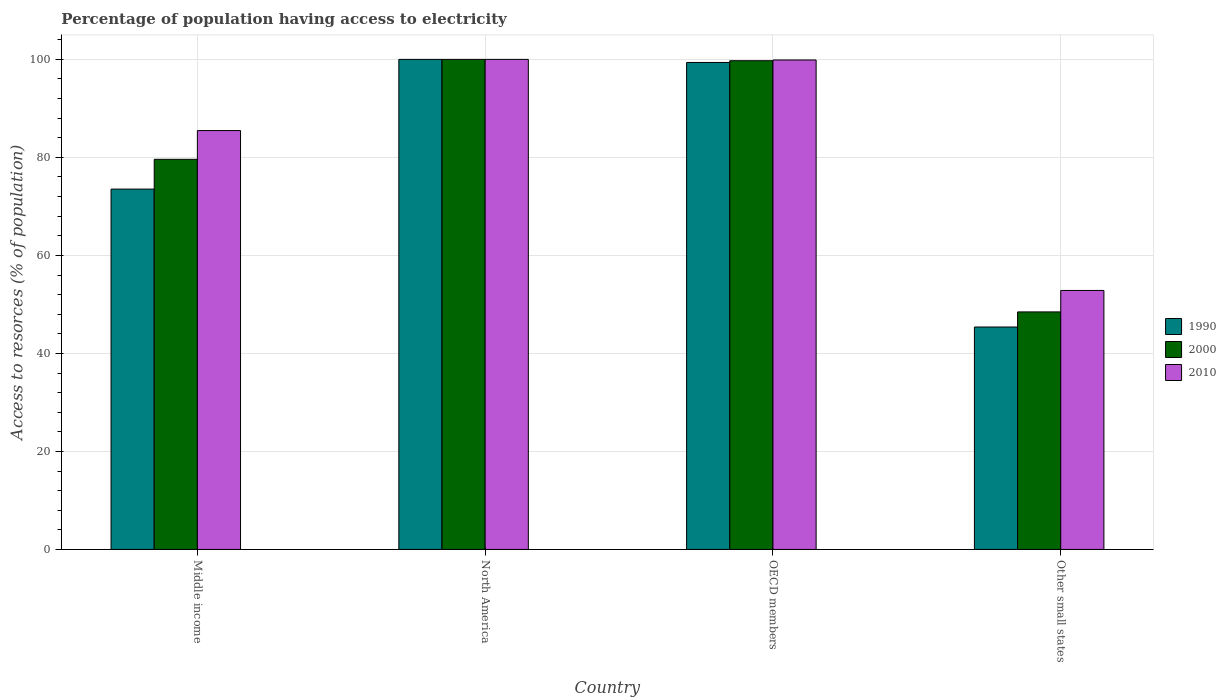How many different coloured bars are there?
Give a very brief answer. 3. How many groups of bars are there?
Provide a short and direct response. 4. Are the number of bars on each tick of the X-axis equal?
Ensure brevity in your answer.  Yes. How many bars are there on the 2nd tick from the left?
Your answer should be compact. 3. What is the label of the 4th group of bars from the left?
Ensure brevity in your answer.  Other small states. What is the percentage of population having access to electricity in 1990 in North America?
Give a very brief answer. 100. Across all countries, what is the maximum percentage of population having access to electricity in 2000?
Your answer should be compact. 100. Across all countries, what is the minimum percentage of population having access to electricity in 1990?
Offer a very short reply. 45.39. In which country was the percentage of population having access to electricity in 2010 minimum?
Make the answer very short. Other small states. What is the total percentage of population having access to electricity in 1990 in the graph?
Your answer should be compact. 318.29. What is the difference between the percentage of population having access to electricity in 2010 in Middle income and that in OECD members?
Ensure brevity in your answer.  -14.41. What is the difference between the percentage of population having access to electricity in 1990 in North America and the percentage of population having access to electricity in 2010 in Middle income?
Keep it short and to the point. 14.53. What is the average percentage of population having access to electricity in 1990 per country?
Give a very brief answer. 79.57. What is the difference between the percentage of population having access to electricity of/in 2000 and percentage of population having access to electricity of/in 2010 in Other small states?
Offer a terse response. -4.38. In how many countries, is the percentage of population having access to electricity in 1990 greater than 64 %?
Provide a short and direct response. 3. What is the ratio of the percentage of population having access to electricity in 1990 in North America to that in OECD members?
Offer a terse response. 1.01. Is the percentage of population having access to electricity in 1990 in OECD members less than that in Other small states?
Your answer should be very brief. No. Is the difference between the percentage of population having access to electricity in 2000 in Middle income and North America greater than the difference between the percentage of population having access to electricity in 2010 in Middle income and North America?
Offer a very short reply. No. What is the difference between the highest and the second highest percentage of population having access to electricity in 2010?
Provide a succinct answer. -0.12. What is the difference between the highest and the lowest percentage of population having access to electricity in 1990?
Make the answer very short. 54.61. What does the 3rd bar from the left in OECD members represents?
Your answer should be very brief. 2010. What does the 2nd bar from the right in Middle income represents?
Make the answer very short. 2000. What is the difference between two consecutive major ticks on the Y-axis?
Your answer should be very brief. 20. Are the values on the major ticks of Y-axis written in scientific E-notation?
Make the answer very short. No. What is the title of the graph?
Your answer should be very brief. Percentage of population having access to electricity. What is the label or title of the Y-axis?
Give a very brief answer. Access to resorces (% of population). What is the Access to resorces (% of population) of 1990 in Middle income?
Offer a very short reply. 73.53. What is the Access to resorces (% of population) of 2000 in Middle income?
Provide a short and direct response. 79.61. What is the Access to resorces (% of population) in 2010 in Middle income?
Keep it short and to the point. 85.47. What is the Access to resorces (% of population) in 1990 in North America?
Your response must be concise. 100. What is the Access to resorces (% of population) of 2000 in North America?
Your answer should be compact. 100. What is the Access to resorces (% of population) in 2010 in North America?
Your answer should be very brief. 100. What is the Access to resorces (% of population) of 1990 in OECD members?
Offer a terse response. 99.37. What is the Access to resorces (% of population) in 2000 in OECD members?
Give a very brief answer. 99.72. What is the Access to resorces (% of population) in 2010 in OECD members?
Make the answer very short. 99.88. What is the Access to resorces (% of population) of 1990 in Other small states?
Keep it short and to the point. 45.39. What is the Access to resorces (% of population) of 2000 in Other small states?
Provide a short and direct response. 48.47. What is the Access to resorces (% of population) in 2010 in Other small states?
Your answer should be compact. 52.85. Across all countries, what is the maximum Access to resorces (% of population) of 1990?
Offer a terse response. 100. Across all countries, what is the maximum Access to resorces (% of population) in 2000?
Your response must be concise. 100. Across all countries, what is the minimum Access to resorces (% of population) of 1990?
Keep it short and to the point. 45.39. Across all countries, what is the minimum Access to resorces (% of population) of 2000?
Ensure brevity in your answer.  48.47. Across all countries, what is the minimum Access to resorces (% of population) in 2010?
Ensure brevity in your answer.  52.85. What is the total Access to resorces (% of population) of 1990 in the graph?
Your answer should be very brief. 318.29. What is the total Access to resorces (% of population) of 2000 in the graph?
Keep it short and to the point. 327.8. What is the total Access to resorces (% of population) of 2010 in the graph?
Your answer should be compact. 338.2. What is the difference between the Access to resorces (% of population) in 1990 in Middle income and that in North America?
Provide a succinct answer. -26.47. What is the difference between the Access to resorces (% of population) in 2000 in Middle income and that in North America?
Offer a terse response. -20.39. What is the difference between the Access to resorces (% of population) of 2010 in Middle income and that in North America?
Ensure brevity in your answer.  -14.53. What is the difference between the Access to resorces (% of population) of 1990 in Middle income and that in OECD members?
Give a very brief answer. -25.84. What is the difference between the Access to resorces (% of population) of 2000 in Middle income and that in OECD members?
Give a very brief answer. -20.12. What is the difference between the Access to resorces (% of population) in 2010 in Middle income and that in OECD members?
Provide a short and direct response. -14.41. What is the difference between the Access to resorces (% of population) in 1990 in Middle income and that in Other small states?
Your answer should be compact. 28.14. What is the difference between the Access to resorces (% of population) of 2000 in Middle income and that in Other small states?
Make the answer very short. 31.14. What is the difference between the Access to resorces (% of population) of 2010 in Middle income and that in Other small states?
Provide a short and direct response. 32.62. What is the difference between the Access to resorces (% of population) of 1990 in North America and that in OECD members?
Provide a succinct answer. 0.63. What is the difference between the Access to resorces (% of population) of 2000 in North America and that in OECD members?
Your answer should be very brief. 0.28. What is the difference between the Access to resorces (% of population) of 2010 in North America and that in OECD members?
Your answer should be compact. 0.12. What is the difference between the Access to resorces (% of population) of 1990 in North America and that in Other small states?
Provide a succinct answer. 54.61. What is the difference between the Access to resorces (% of population) of 2000 in North America and that in Other small states?
Give a very brief answer. 51.53. What is the difference between the Access to resorces (% of population) in 2010 in North America and that in Other small states?
Ensure brevity in your answer.  47.15. What is the difference between the Access to resorces (% of population) in 1990 in OECD members and that in Other small states?
Offer a very short reply. 53.98. What is the difference between the Access to resorces (% of population) of 2000 in OECD members and that in Other small states?
Give a very brief answer. 51.25. What is the difference between the Access to resorces (% of population) in 2010 in OECD members and that in Other small states?
Give a very brief answer. 47.03. What is the difference between the Access to resorces (% of population) in 1990 in Middle income and the Access to resorces (% of population) in 2000 in North America?
Offer a very short reply. -26.47. What is the difference between the Access to resorces (% of population) in 1990 in Middle income and the Access to resorces (% of population) in 2010 in North America?
Keep it short and to the point. -26.47. What is the difference between the Access to resorces (% of population) in 2000 in Middle income and the Access to resorces (% of population) in 2010 in North America?
Offer a terse response. -20.39. What is the difference between the Access to resorces (% of population) in 1990 in Middle income and the Access to resorces (% of population) in 2000 in OECD members?
Provide a short and direct response. -26.19. What is the difference between the Access to resorces (% of population) in 1990 in Middle income and the Access to resorces (% of population) in 2010 in OECD members?
Your answer should be compact. -26.35. What is the difference between the Access to resorces (% of population) of 2000 in Middle income and the Access to resorces (% of population) of 2010 in OECD members?
Ensure brevity in your answer.  -20.27. What is the difference between the Access to resorces (% of population) in 1990 in Middle income and the Access to resorces (% of population) in 2000 in Other small states?
Provide a succinct answer. 25.06. What is the difference between the Access to resorces (% of population) in 1990 in Middle income and the Access to resorces (% of population) in 2010 in Other small states?
Your response must be concise. 20.68. What is the difference between the Access to resorces (% of population) of 2000 in Middle income and the Access to resorces (% of population) of 2010 in Other small states?
Provide a short and direct response. 26.76. What is the difference between the Access to resorces (% of population) of 1990 in North America and the Access to resorces (% of population) of 2000 in OECD members?
Give a very brief answer. 0.28. What is the difference between the Access to resorces (% of population) in 1990 in North America and the Access to resorces (% of population) in 2010 in OECD members?
Give a very brief answer. 0.12. What is the difference between the Access to resorces (% of population) in 2000 in North America and the Access to resorces (% of population) in 2010 in OECD members?
Your answer should be compact. 0.12. What is the difference between the Access to resorces (% of population) in 1990 in North America and the Access to resorces (% of population) in 2000 in Other small states?
Make the answer very short. 51.53. What is the difference between the Access to resorces (% of population) of 1990 in North America and the Access to resorces (% of population) of 2010 in Other small states?
Your answer should be compact. 47.15. What is the difference between the Access to resorces (% of population) of 2000 in North America and the Access to resorces (% of population) of 2010 in Other small states?
Your answer should be compact. 47.15. What is the difference between the Access to resorces (% of population) in 1990 in OECD members and the Access to resorces (% of population) in 2000 in Other small states?
Keep it short and to the point. 50.9. What is the difference between the Access to resorces (% of population) in 1990 in OECD members and the Access to resorces (% of population) in 2010 in Other small states?
Your response must be concise. 46.52. What is the difference between the Access to resorces (% of population) in 2000 in OECD members and the Access to resorces (% of population) in 2010 in Other small states?
Your answer should be compact. 46.88. What is the average Access to resorces (% of population) of 1990 per country?
Give a very brief answer. 79.57. What is the average Access to resorces (% of population) in 2000 per country?
Your answer should be very brief. 81.95. What is the average Access to resorces (% of population) in 2010 per country?
Your answer should be very brief. 84.55. What is the difference between the Access to resorces (% of population) in 1990 and Access to resorces (% of population) in 2000 in Middle income?
Provide a short and direct response. -6.08. What is the difference between the Access to resorces (% of population) of 1990 and Access to resorces (% of population) of 2010 in Middle income?
Your answer should be compact. -11.94. What is the difference between the Access to resorces (% of population) in 2000 and Access to resorces (% of population) in 2010 in Middle income?
Provide a short and direct response. -5.87. What is the difference between the Access to resorces (% of population) of 1990 and Access to resorces (% of population) of 2000 in North America?
Your answer should be very brief. 0. What is the difference between the Access to resorces (% of population) of 1990 and Access to resorces (% of population) of 2010 in North America?
Your answer should be very brief. 0. What is the difference between the Access to resorces (% of population) in 1990 and Access to resorces (% of population) in 2000 in OECD members?
Provide a succinct answer. -0.35. What is the difference between the Access to resorces (% of population) of 1990 and Access to resorces (% of population) of 2010 in OECD members?
Offer a terse response. -0.51. What is the difference between the Access to resorces (% of population) of 2000 and Access to resorces (% of population) of 2010 in OECD members?
Provide a short and direct response. -0.15. What is the difference between the Access to resorces (% of population) of 1990 and Access to resorces (% of population) of 2000 in Other small states?
Provide a short and direct response. -3.08. What is the difference between the Access to resorces (% of population) in 1990 and Access to resorces (% of population) in 2010 in Other small states?
Your answer should be compact. -7.46. What is the difference between the Access to resorces (% of population) of 2000 and Access to resorces (% of population) of 2010 in Other small states?
Offer a terse response. -4.38. What is the ratio of the Access to resorces (% of population) in 1990 in Middle income to that in North America?
Give a very brief answer. 0.74. What is the ratio of the Access to resorces (% of population) of 2000 in Middle income to that in North America?
Give a very brief answer. 0.8. What is the ratio of the Access to resorces (% of population) of 2010 in Middle income to that in North America?
Provide a succinct answer. 0.85. What is the ratio of the Access to resorces (% of population) of 1990 in Middle income to that in OECD members?
Give a very brief answer. 0.74. What is the ratio of the Access to resorces (% of population) of 2000 in Middle income to that in OECD members?
Your answer should be very brief. 0.8. What is the ratio of the Access to resorces (% of population) in 2010 in Middle income to that in OECD members?
Provide a short and direct response. 0.86. What is the ratio of the Access to resorces (% of population) in 1990 in Middle income to that in Other small states?
Offer a terse response. 1.62. What is the ratio of the Access to resorces (% of population) of 2000 in Middle income to that in Other small states?
Provide a succinct answer. 1.64. What is the ratio of the Access to resorces (% of population) of 2010 in Middle income to that in Other small states?
Provide a succinct answer. 1.62. What is the ratio of the Access to resorces (% of population) in 1990 in North America to that in OECD members?
Keep it short and to the point. 1.01. What is the ratio of the Access to resorces (% of population) of 1990 in North America to that in Other small states?
Your answer should be very brief. 2.2. What is the ratio of the Access to resorces (% of population) of 2000 in North America to that in Other small states?
Your response must be concise. 2.06. What is the ratio of the Access to resorces (% of population) of 2010 in North America to that in Other small states?
Ensure brevity in your answer.  1.89. What is the ratio of the Access to resorces (% of population) of 1990 in OECD members to that in Other small states?
Your answer should be compact. 2.19. What is the ratio of the Access to resorces (% of population) of 2000 in OECD members to that in Other small states?
Your answer should be compact. 2.06. What is the ratio of the Access to resorces (% of population) in 2010 in OECD members to that in Other small states?
Your answer should be very brief. 1.89. What is the difference between the highest and the second highest Access to resorces (% of population) of 1990?
Your answer should be very brief. 0.63. What is the difference between the highest and the second highest Access to resorces (% of population) in 2000?
Provide a short and direct response. 0.28. What is the difference between the highest and the second highest Access to resorces (% of population) of 2010?
Provide a succinct answer. 0.12. What is the difference between the highest and the lowest Access to resorces (% of population) in 1990?
Your response must be concise. 54.61. What is the difference between the highest and the lowest Access to resorces (% of population) in 2000?
Provide a short and direct response. 51.53. What is the difference between the highest and the lowest Access to resorces (% of population) of 2010?
Make the answer very short. 47.15. 